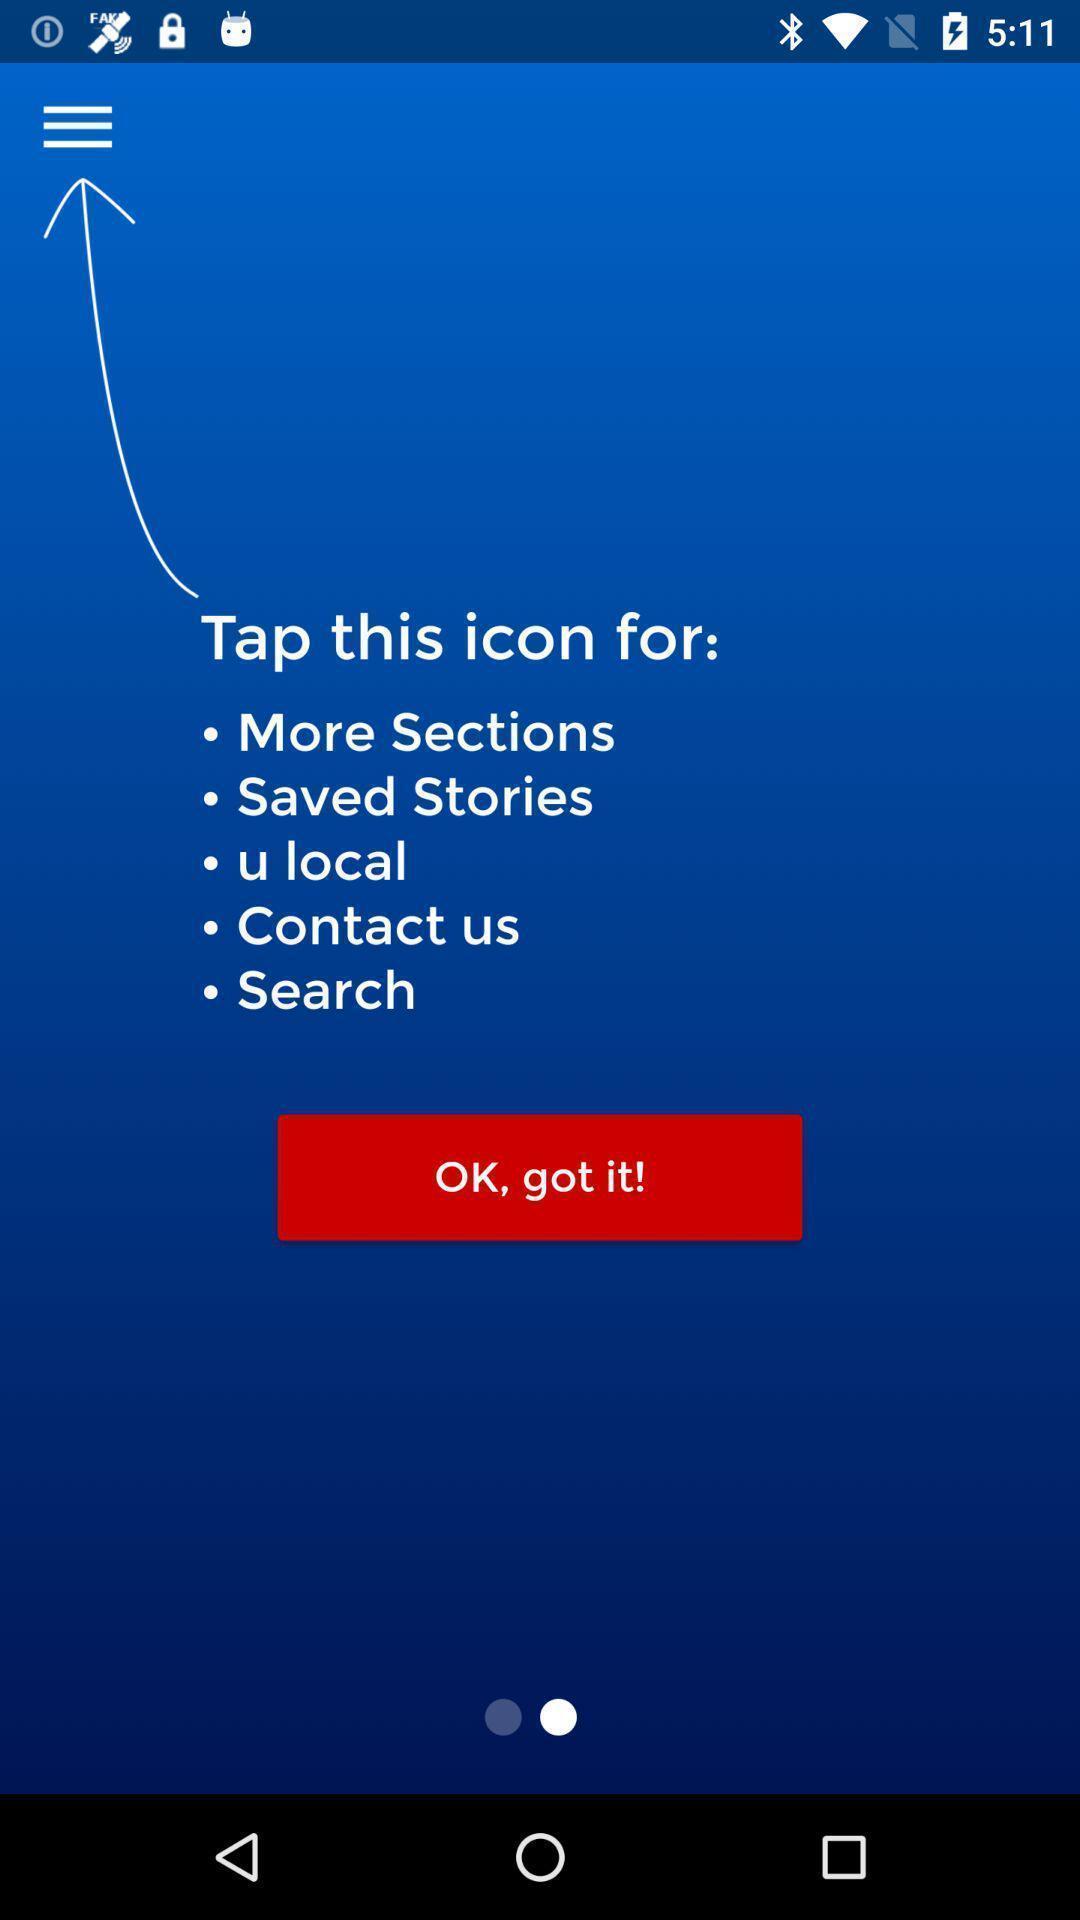Summarize the main components in this picture. Page showing the tutorial of the menu icon. 